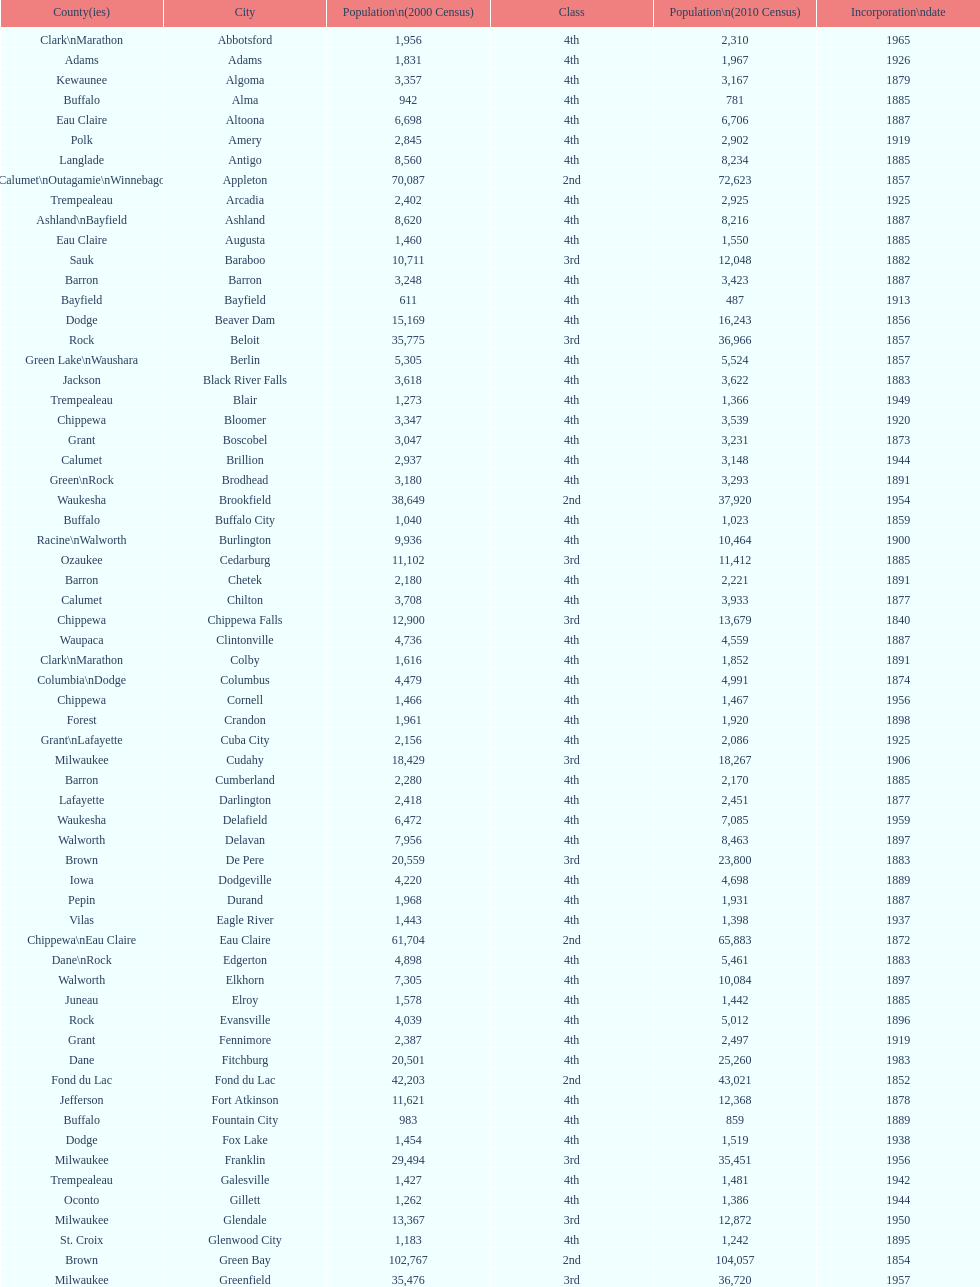How many cities are in wisconsin? 190. 